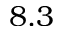<formula> <loc_0><loc_0><loc_500><loc_500>8 . 3</formula> 